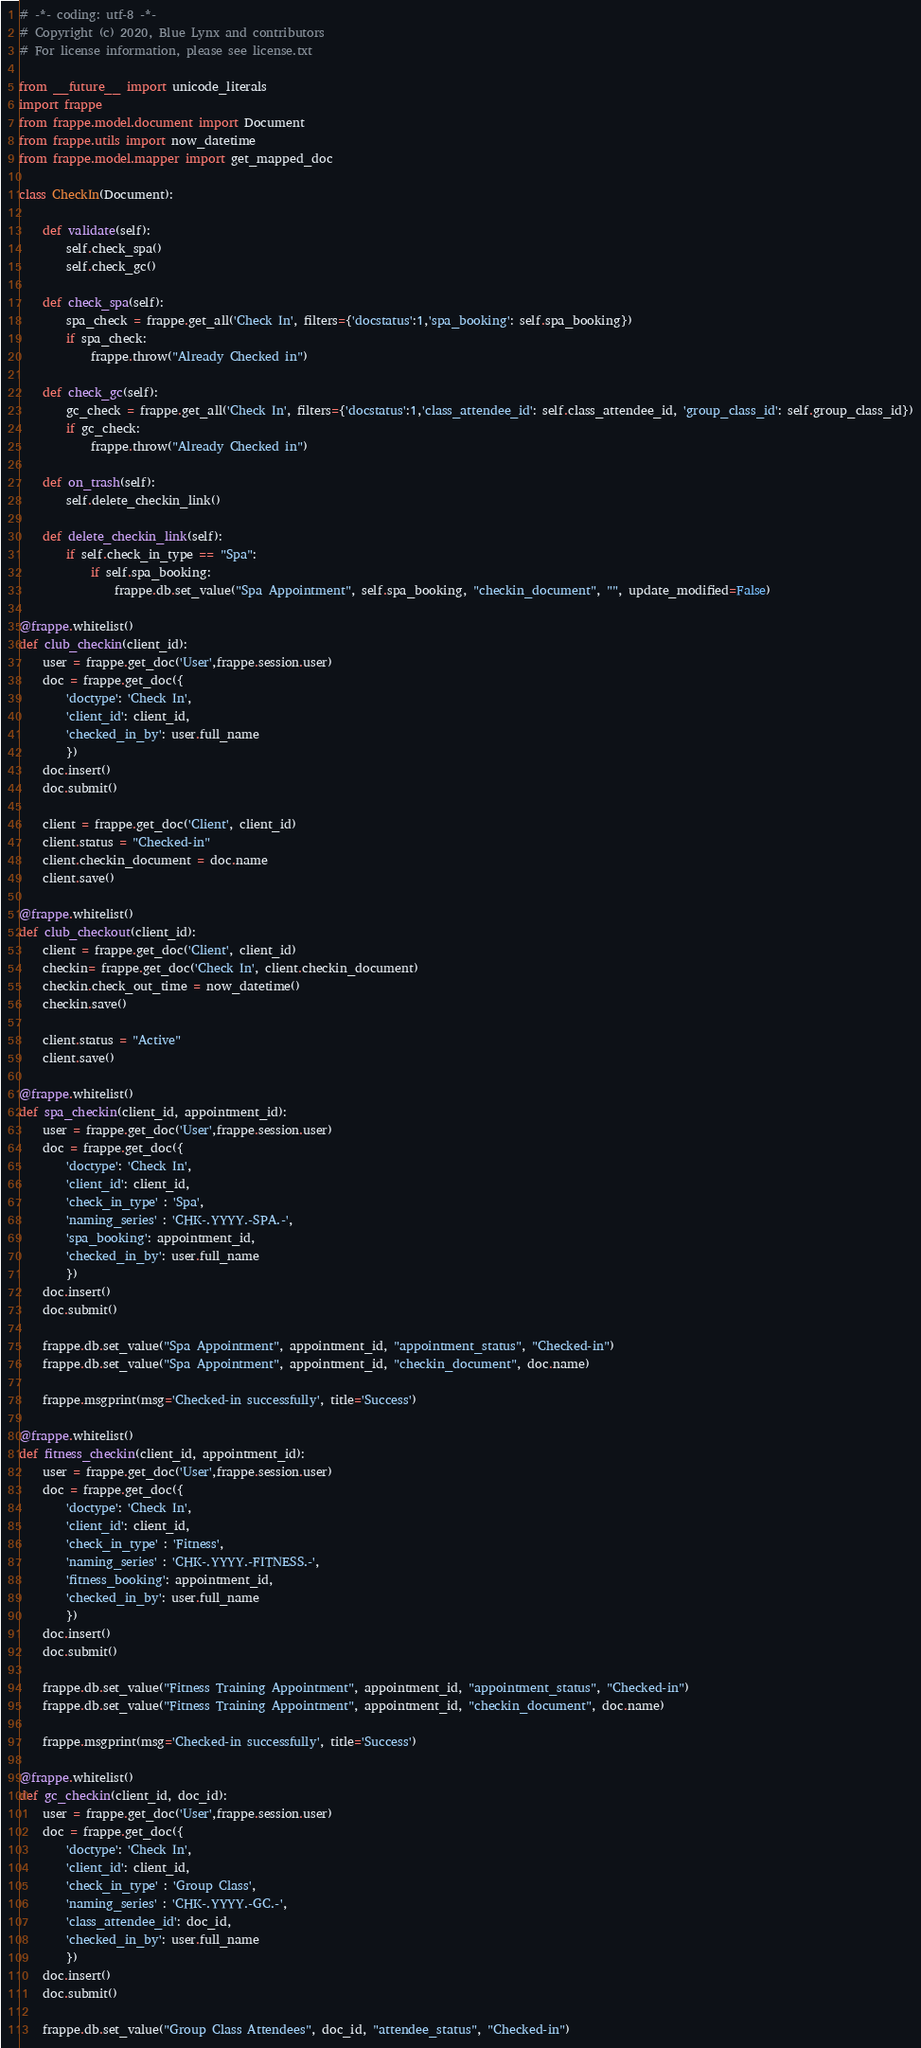<code> <loc_0><loc_0><loc_500><loc_500><_Python_># -*- coding: utf-8 -*-
# Copyright (c) 2020, Blue Lynx and contributors
# For license information, please see license.txt

from __future__ import unicode_literals
import frappe
from frappe.model.document import Document
from frappe.utils import now_datetime
from frappe.model.mapper import get_mapped_doc

class CheckIn(Document):

	def validate(self):
		self.check_spa()
		self.check_gc()

	def check_spa(self):
		spa_check = frappe.get_all('Check In', filters={'docstatus':1,'spa_booking': self.spa_booking})
		if spa_check:
			frappe.throw("Already Checked in")
	
	def check_gc(self):
		gc_check = frappe.get_all('Check In', filters={'docstatus':1,'class_attendee_id': self.class_attendee_id, 'group_class_id': self.group_class_id})
		if gc_check:
			frappe.throw("Already Checked in")

	def on_trash(self):
		self.delete_checkin_link()

	def delete_checkin_link(self):
		if self.check_in_type == "Spa":
			if self.spa_booking:
				frappe.db.set_value("Spa Appointment", self.spa_booking, "checkin_document", "", update_modified=False)

@frappe.whitelist()
def club_checkin(client_id):
	user = frappe.get_doc('User',frappe.session.user)
	doc = frappe.get_doc({
        'doctype': 'Check In',
        'client_id': client_id,
		'checked_in_by': user.full_name
        })
	doc.insert()
	doc.submit()

	client = frappe.get_doc('Client', client_id)
	client.status = "Checked-in"
	client.checkin_document = doc.name
	client.save()

@frappe.whitelist()
def club_checkout(client_id):
	client = frappe.get_doc('Client', client_id)
	checkin= frappe.get_doc('Check In', client.checkin_document)
	checkin.check_out_time = now_datetime()
	checkin.save()

	client.status = "Active"
	client.save()

@frappe.whitelist()
def spa_checkin(client_id, appointment_id):
	user = frappe.get_doc('User',frappe.session.user)
	doc = frappe.get_doc({
        'doctype': 'Check In',
        'client_id': client_id,
		'check_in_type' : 'Spa',
		'naming_series' : 'CHK-.YYYY.-SPA.-',
		'spa_booking': appointment_id,
		'checked_in_by': user.full_name
        })
	doc.insert()
	doc.submit()
	
	frappe.db.set_value("Spa Appointment", appointment_id, "appointment_status", "Checked-in")
	frappe.db.set_value("Spa Appointment", appointment_id, "checkin_document", doc.name)

	frappe.msgprint(msg='Checked-in successfully', title='Success')

@frappe.whitelist()
def fitness_checkin(client_id, appointment_id):
	user = frappe.get_doc('User',frappe.session.user)
	doc = frappe.get_doc({
        'doctype': 'Check In',
        'client_id': client_id,
		'check_in_type' : 'Fitness',
		'naming_series' : 'CHK-.YYYY.-FITNESS.-',
		'fitness_booking': appointment_id,
		'checked_in_by': user.full_name
        })
	doc.insert()
	doc.submit()
	
	frappe.db.set_value("Fitness Training Appointment", appointment_id, "appointment_status", "Checked-in")
	frappe.db.set_value("Fitness Training Appointment", appointment_id, "checkin_document", doc.name)

	frappe.msgprint(msg='Checked-in successfully', title='Success')

@frappe.whitelist()
def gc_checkin(client_id, doc_id):
	user = frappe.get_doc('User',frappe.session.user)
	doc = frappe.get_doc({
        'doctype': 'Check In',
        'client_id': client_id,
		'check_in_type' : 'Group Class',
		'naming_series' : 'CHK-.YYYY.-GC.-',
		'class_attendee_id': doc_id,
		'checked_in_by': user.full_name
        })
	doc.insert()
	doc.submit()
	
	frappe.db.set_value("Group Class Attendees", doc_id, "attendee_status", "Checked-in")</code> 